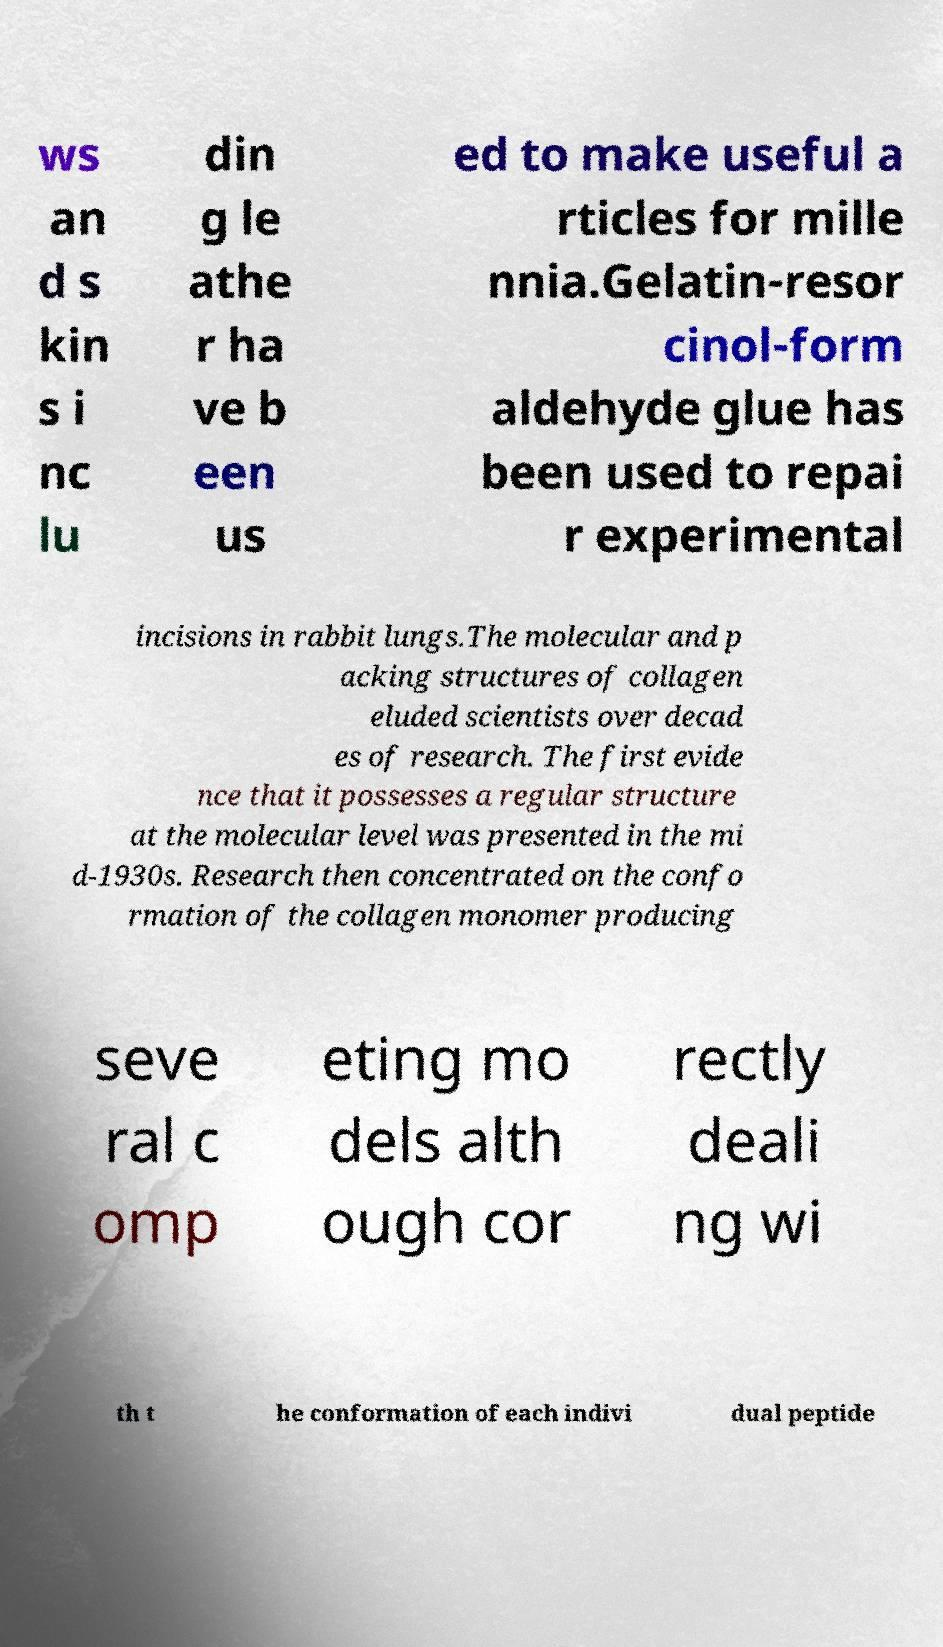For documentation purposes, I need the text within this image transcribed. Could you provide that? ws an d s kin s i nc lu din g le athe r ha ve b een us ed to make useful a rticles for mille nnia.Gelatin-resor cinol-form aldehyde glue has been used to repai r experimental incisions in rabbit lungs.The molecular and p acking structures of collagen eluded scientists over decad es of research. The first evide nce that it possesses a regular structure at the molecular level was presented in the mi d-1930s. Research then concentrated on the confo rmation of the collagen monomer producing seve ral c omp eting mo dels alth ough cor rectly deali ng wi th t he conformation of each indivi dual peptide 